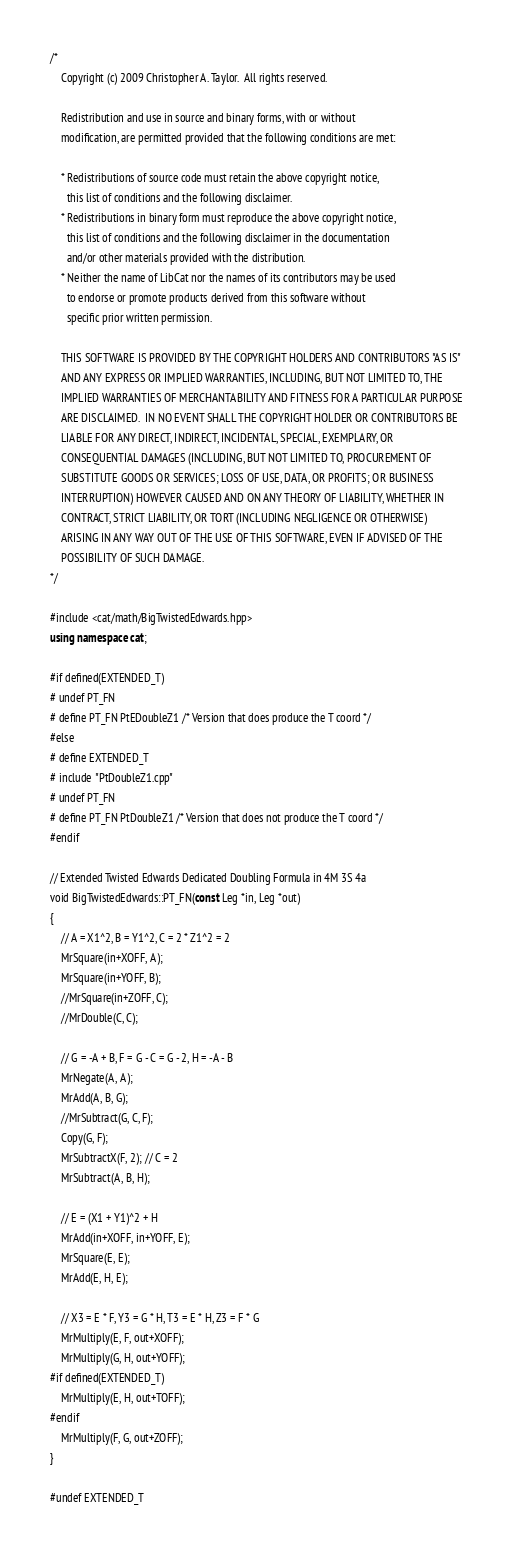Convert code to text. <code><loc_0><loc_0><loc_500><loc_500><_C++_>/*
	Copyright (c) 2009 Christopher A. Taylor.  All rights reserved.

	Redistribution and use in source and binary forms, with or without
	modification, are permitted provided that the following conditions are met:

	* Redistributions of source code must retain the above copyright notice,
	  this list of conditions and the following disclaimer.
	* Redistributions in binary form must reproduce the above copyright notice,
	  this list of conditions and the following disclaimer in the documentation
	  and/or other materials provided with the distribution.
	* Neither the name of LibCat nor the names of its contributors may be used
	  to endorse or promote products derived from this software without
	  specific prior written permission.

	THIS SOFTWARE IS PROVIDED BY THE COPYRIGHT HOLDERS AND CONTRIBUTORS "AS IS"
	AND ANY EXPRESS OR IMPLIED WARRANTIES, INCLUDING, BUT NOT LIMITED TO, THE
	IMPLIED WARRANTIES OF MERCHANTABILITY AND FITNESS FOR A PARTICULAR PURPOSE
	ARE DISCLAIMED.  IN NO EVENT SHALL THE COPYRIGHT HOLDER OR CONTRIBUTORS BE
	LIABLE FOR ANY DIRECT, INDIRECT, INCIDENTAL, SPECIAL, EXEMPLARY, OR
	CONSEQUENTIAL DAMAGES (INCLUDING, BUT NOT LIMITED TO, PROCUREMENT OF
	SUBSTITUTE GOODS OR SERVICES; LOSS OF USE, DATA, OR PROFITS; OR BUSINESS
	INTERRUPTION) HOWEVER CAUSED AND ON ANY THEORY OF LIABILITY, WHETHER IN
	CONTRACT, STRICT LIABILITY, OR TORT (INCLUDING NEGLIGENCE OR OTHERWISE)
	ARISING IN ANY WAY OUT OF THE USE OF THIS SOFTWARE, EVEN IF ADVISED OF THE
	POSSIBILITY OF SUCH DAMAGE.
*/

#include <cat/math/BigTwistedEdwards.hpp>
using namespace cat;

#if defined(EXTENDED_T)
# undef PT_FN
# define PT_FN PtEDoubleZ1 /* Version that does produce the T coord */
#else
# define EXTENDED_T
# include "PtDoubleZ1.cpp"
# undef PT_FN
# define PT_FN PtDoubleZ1 /* Version that does not produce the T coord */
#endif

// Extended Twisted Edwards Dedicated Doubling Formula in 4M 3S 4a
void BigTwistedEdwards::PT_FN(const Leg *in, Leg *out)
{
    // A = X1^2, B = Y1^2, C = 2 * Z1^2 = 2
    MrSquare(in+XOFF, A);
    MrSquare(in+YOFF, B);
    //MrSquare(in+ZOFF, C);
    //MrDouble(C, C);

    // G = -A + B, F = G - C = G - 2, H = -A - B
    MrNegate(A, A);
    MrAdd(A, B, G);
    //MrSubtract(G, C, F);
    Copy(G, F);
    MrSubtractX(F, 2); // C = 2
    MrSubtract(A, B, H);

    // E = (X1 + Y1)^2 + H
    MrAdd(in+XOFF, in+YOFF, E);
    MrSquare(E, E);
    MrAdd(E, H, E);

    // X3 = E * F, Y3 = G * H, T3 = E * H, Z3 = F * G
    MrMultiply(E, F, out+XOFF);
    MrMultiply(G, H, out+YOFF);
#if defined(EXTENDED_T)
    MrMultiply(E, H, out+TOFF);
#endif
    MrMultiply(F, G, out+ZOFF);
}

#undef EXTENDED_T
</code> 